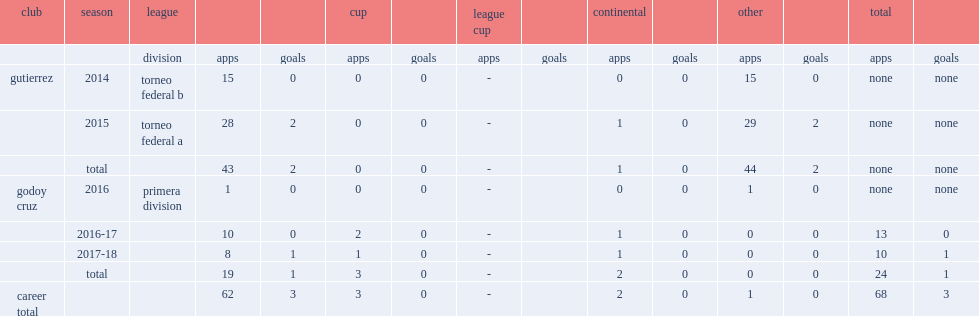Which league did facundo cobos's career begin with gutierrez in 2014? Torneo federal b. 